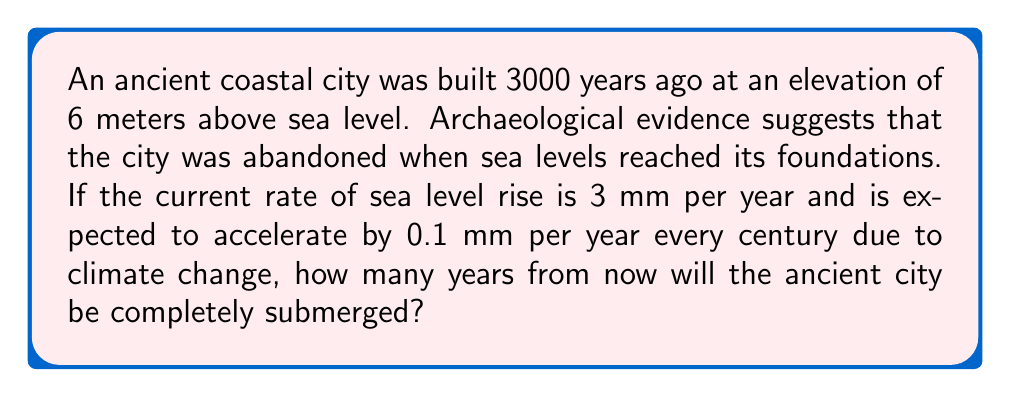What is the answer to this math problem? Let's approach this step-by-step:

1) First, we need to calculate the total sea level rise needed to submerge the city:
   $6 \text{ meters} = 6000 \text{ mm}$

2) Now, let's set up a function for the sea level rise over time:
   Let $t$ be the number of centuries from now
   $R(t) = 300t + 5t^2$ (mm)
   Where:
   - $300t$ represents the current rate (3 mm/year * 100 years/century)
   - $5t^2$ represents the acceleration (0.1 mm/year/century * 100 years/century * $t$/2)

3) We need to solve the equation:
   $R(t) = 6000$
   $300t + 5t^2 = 6000$

4) Rearrange the equation:
   $5t^2 + 300t - 6000 = 0$

5) This is a quadratic equation. We can solve it using the quadratic formula:
   $t = \frac{-b \pm \sqrt{b^2 - 4ac}}{2a}$
   Where $a=5$, $b=300$, and $c=-6000$

6) Plugging in the values:
   $t = \frac{-300 \pm \sqrt{300^2 - 4(5)(-6000)}}{2(5)}$
   $= \frac{-300 \pm \sqrt{90000 + 120000}}{10}$
   $= \frac{-300 \pm \sqrt{210000}}{10}$
   $= \frac{-300 \pm 458.26}{10}$

7) This gives us two solutions:
   $t_1 = \frac{-300 + 458.26}{10} = 15.826$ centuries
   $t_2 = \frac{-300 - 458.26}{10} = -75.826$ centuries (discard as it's in the past)

8) Convert to years:
   $15.826 \text{ centuries} = 1582.6 \text{ years}$

Therefore, the city will be submerged in approximately 1583 years from now.
Answer: 1583 years 